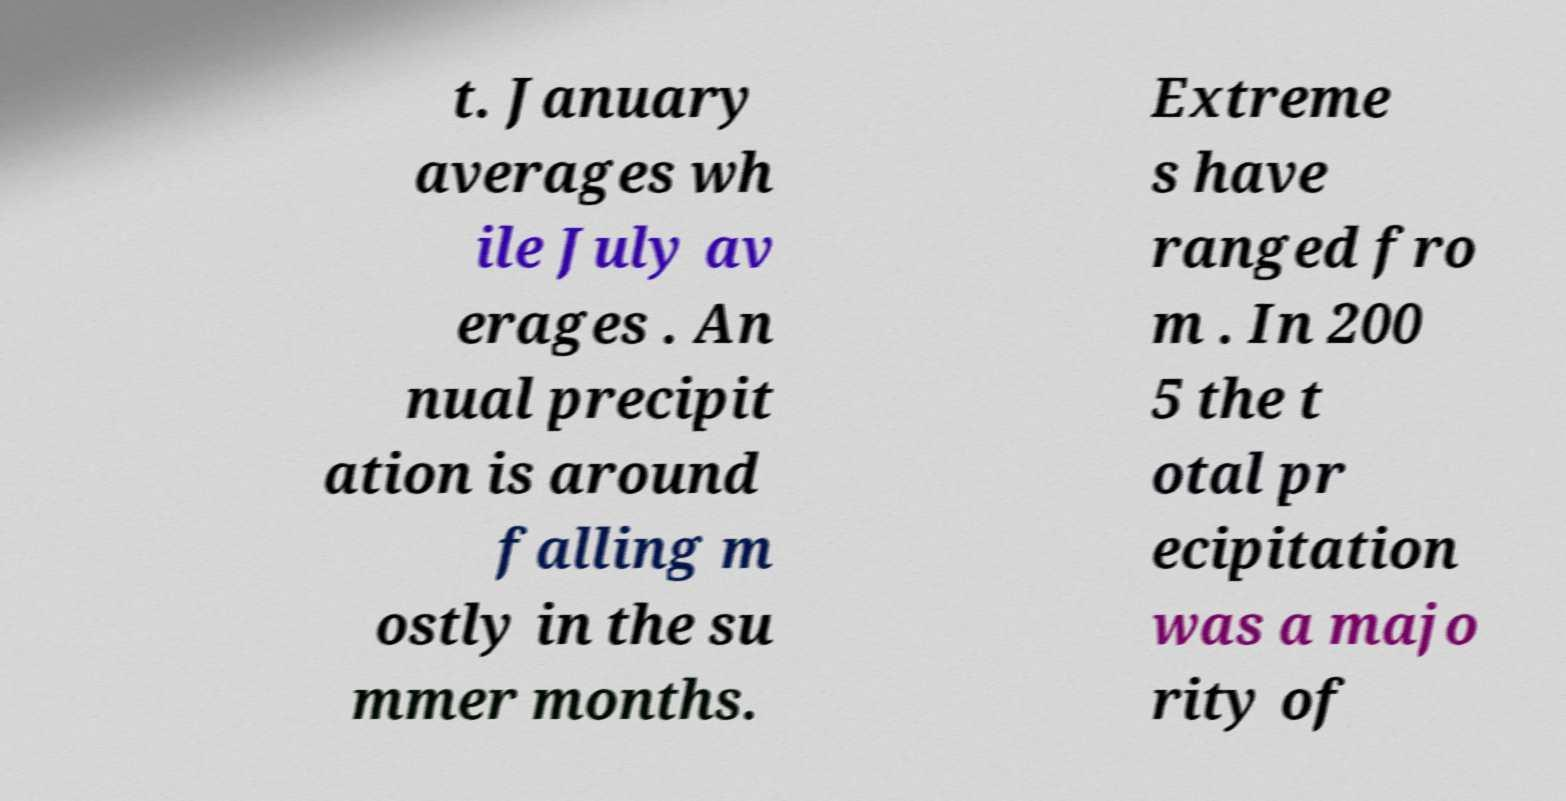Please identify and transcribe the text found in this image. t. January averages wh ile July av erages . An nual precipit ation is around falling m ostly in the su mmer months. Extreme s have ranged fro m . In 200 5 the t otal pr ecipitation was a majo rity of 